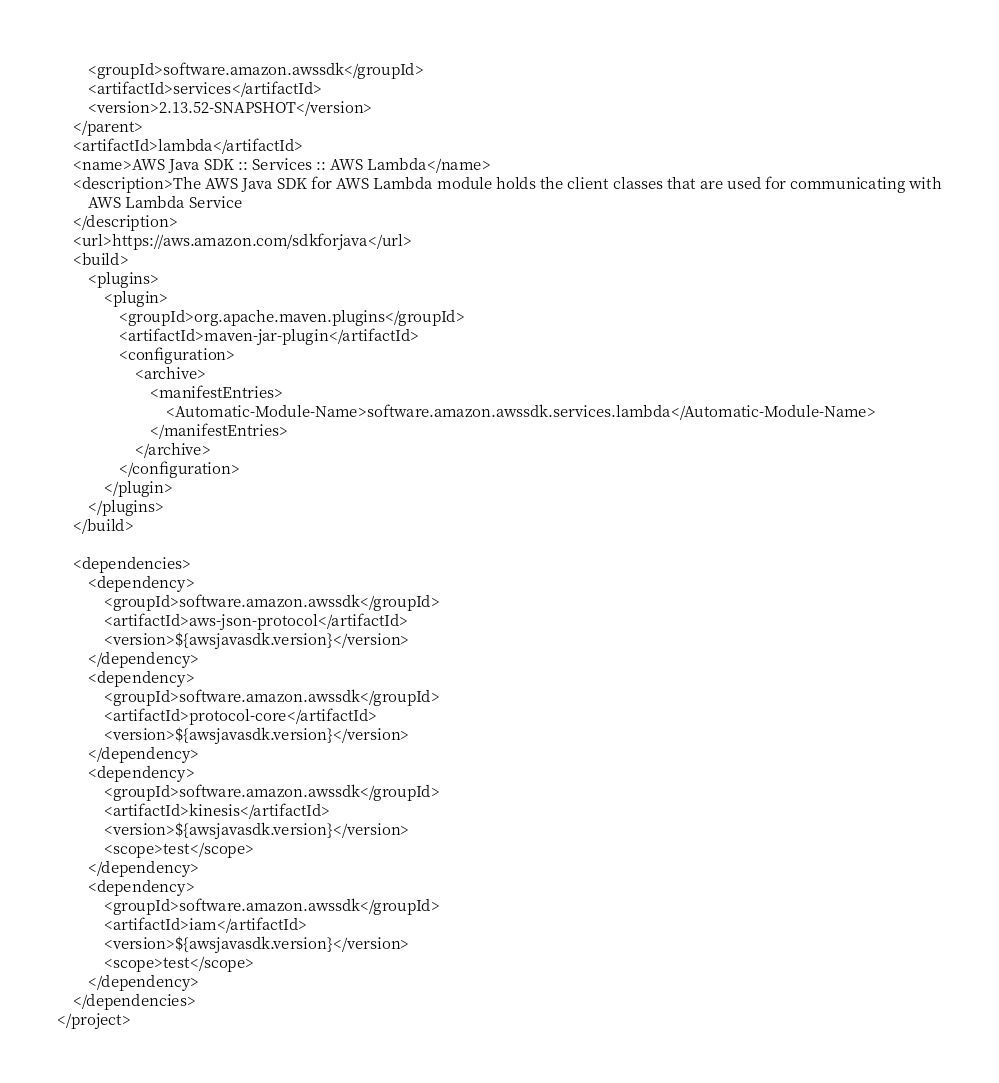Convert code to text. <code><loc_0><loc_0><loc_500><loc_500><_XML_>        <groupId>software.amazon.awssdk</groupId>
        <artifactId>services</artifactId>
        <version>2.13.52-SNAPSHOT</version>
    </parent>
    <artifactId>lambda</artifactId>
    <name>AWS Java SDK :: Services :: AWS Lambda</name>
    <description>The AWS Java SDK for AWS Lambda module holds the client classes that are used for communicating with
        AWS Lambda Service
    </description>
    <url>https://aws.amazon.com/sdkforjava</url>
    <build>
        <plugins>
            <plugin>
                <groupId>org.apache.maven.plugins</groupId>
                <artifactId>maven-jar-plugin</artifactId>
                <configuration>
                    <archive>
                        <manifestEntries>
                            <Automatic-Module-Name>software.amazon.awssdk.services.lambda</Automatic-Module-Name>
                        </manifestEntries>
                    </archive>
                </configuration>
            </plugin>
        </plugins>
    </build>

    <dependencies>
        <dependency>
            <groupId>software.amazon.awssdk</groupId>
            <artifactId>aws-json-protocol</artifactId>
            <version>${awsjavasdk.version}</version>
        </dependency>
        <dependency>
            <groupId>software.amazon.awssdk</groupId>
            <artifactId>protocol-core</artifactId>
            <version>${awsjavasdk.version}</version>
        </dependency>
        <dependency>
            <groupId>software.amazon.awssdk</groupId>
            <artifactId>kinesis</artifactId>
            <version>${awsjavasdk.version}</version>
            <scope>test</scope>
        </dependency>
        <dependency>
            <groupId>software.amazon.awssdk</groupId>
            <artifactId>iam</artifactId>
            <version>${awsjavasdk.version}</version>
            <scope>test</scope>
        </dependency>
    </dependencies>
</project>
</code> 